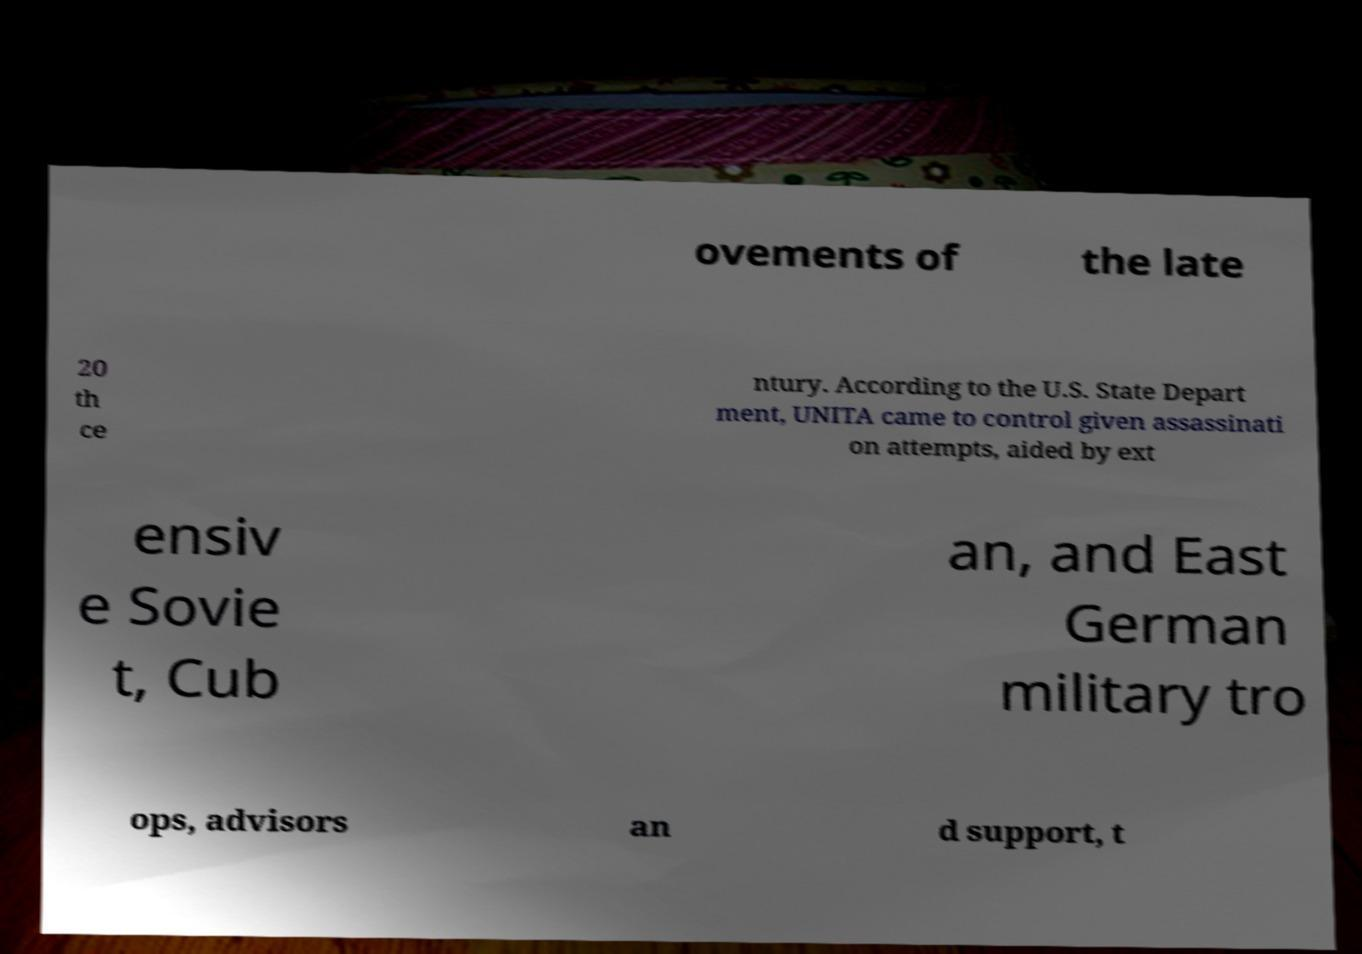For documentation purposes, I need the text within this image transcribed. Could you provide that? ovements of the late 20 th ce ntury. According to the U.S. State Depart ment, UNITA came to control given assassinati on attempts, aided by ext ensiv e Sovie t, Cub an, and East German military tro ops, advisors an d support, t 